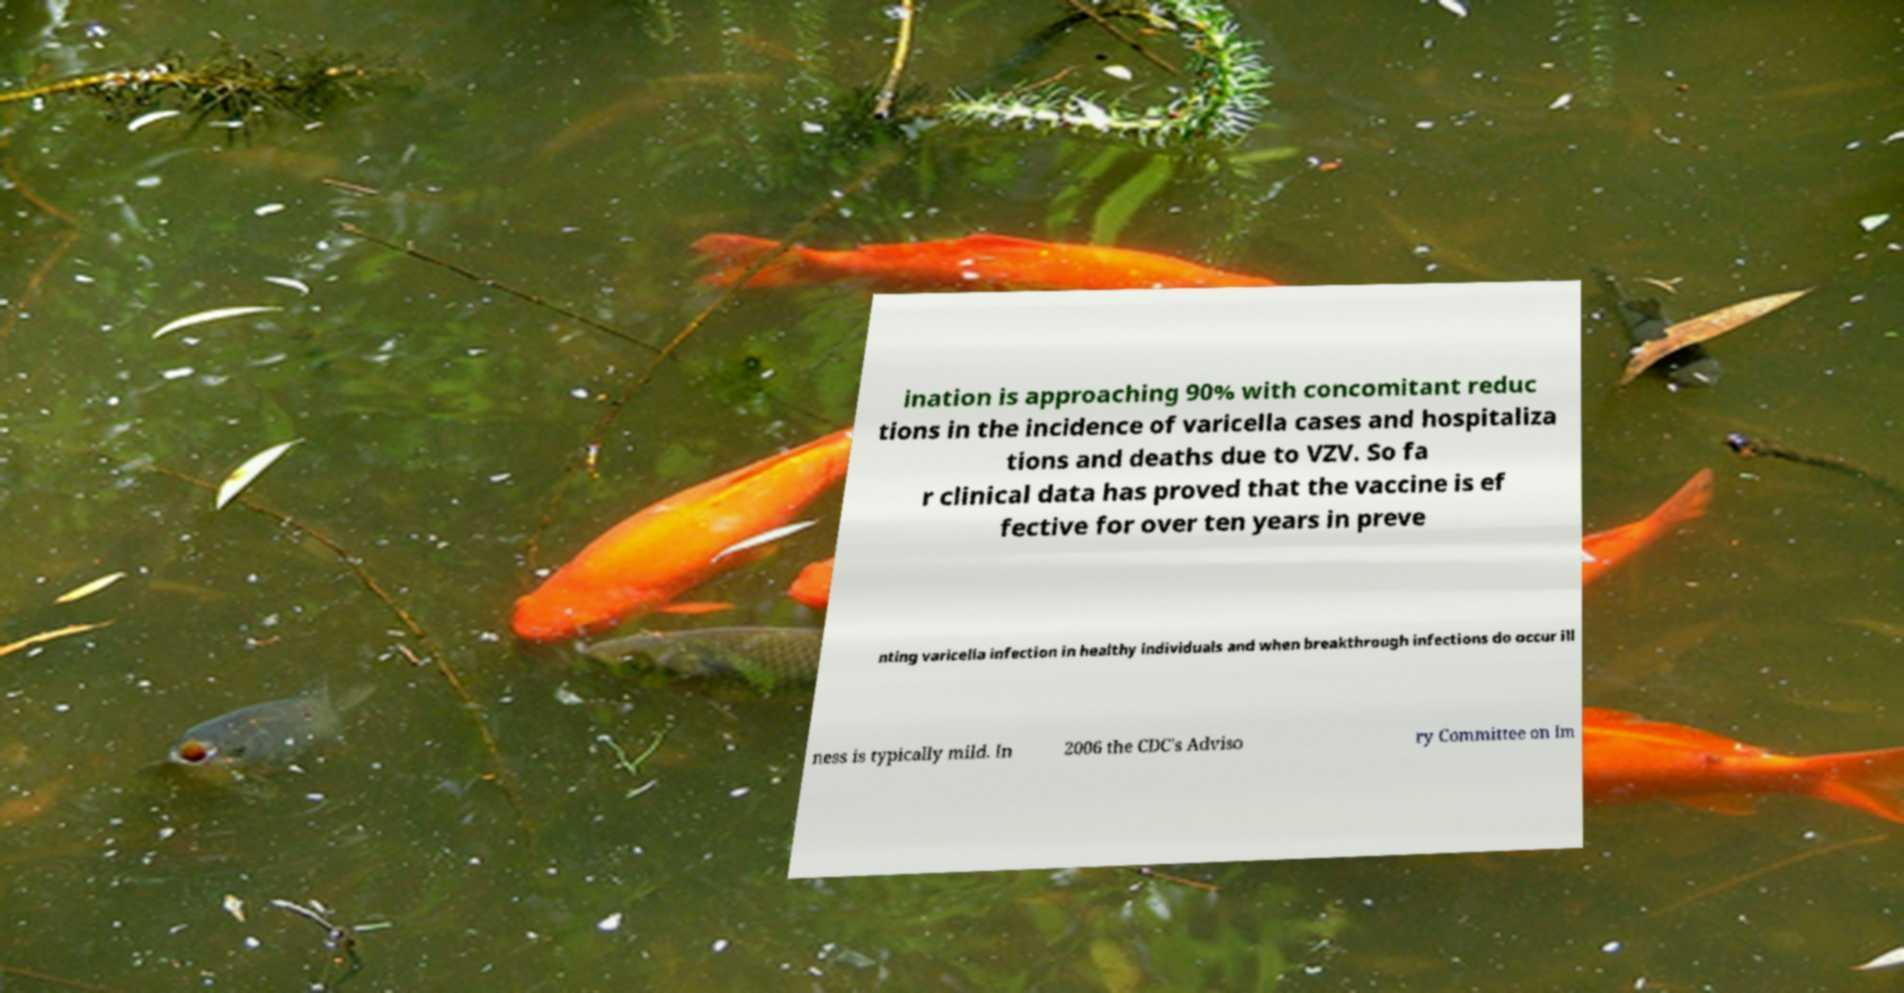For documentation purposes, I need the text within this image transcribed. Could you provide that? ination is approaching 90% with concomitant reduc tions in the incidence of varicella cases and hospitaliza tions and deaths due to VZV. So fa r clinical data has proved that the vaccine is ef fective for over ten years in preve nting varicella infection in healthy individuals and when breakthrough infections do occur ill ness is typically mild. In 2006 the CDC's Adviso ry Committee on Im 